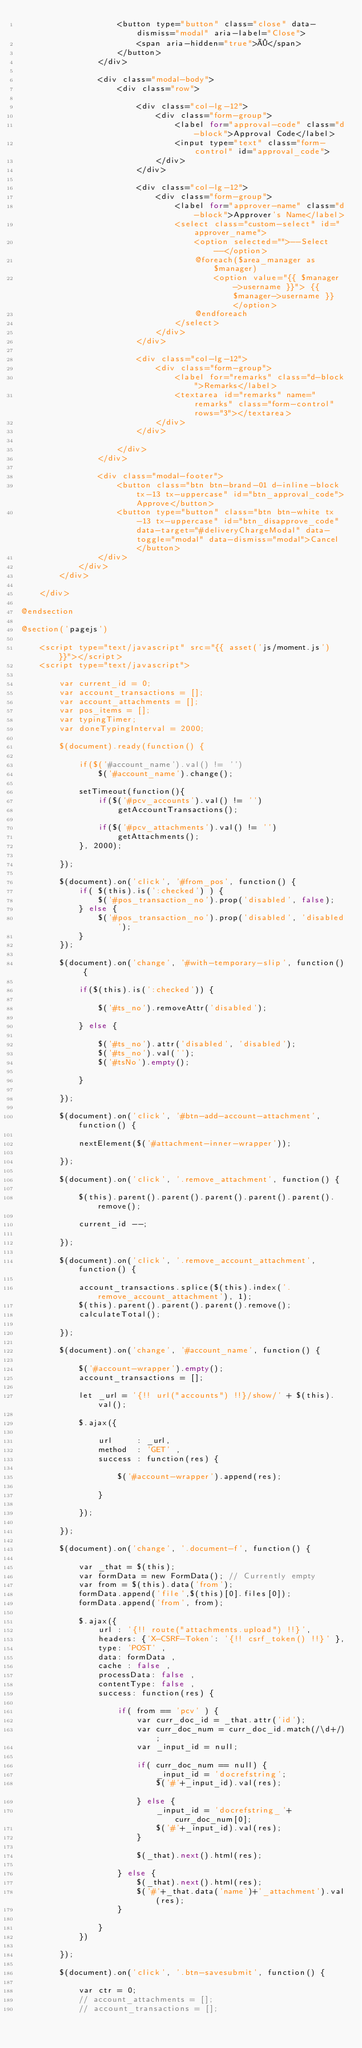<code> <loc_0><loc_0><loc_500><loc_500><_PHP_>					<button type="button" class="close" data-dismiss="modal" aria-label="Close">
						<span aria-hidden="true">×</span>
					</button>
				</div>

				<div class="modal-body">
					<div class="row">
						
						<div class="col-lg-12">
							<div class="form-group">
								<label for="approval-code" class="d-block">Approval Code</label>
								<input type="text" class="form-control" id="approval_code">
							</div>
						</div>

						<div class="col-lg-12">
							<div class="form-group">
								<label for="approver-name" class="d-block">Approver's Name</label>
								<select class="custom-select" id="approver_name">
									<option selected="">--Select--</option>
									@foreach($area_manager as $manager) 
										<option value="{{ $manager->username }}"> {{ $manager->username }} </option>
									@endforeach
								</select>
							</div>
						</div>

						<div class="col-lg-12">
							<div class="form-group">
								<label for="remarks" class="d-block">Remarks</label>
								<textarea id="remarks" name="remarks" class="form-control" rows="3"></textarea>
							</div>
						</div>

					</div>
				</div>

				<div class="modal-footer">
					<button class="btn btn-brand-01 d-inline-block tx-13 tx-uppercase" id="btn_approval_code">Approve</button>
					<button type="button" class="btn btn-white tx-13 tx-uppercase" id="btn_disapprove_code" data-target="#deliveryChargeModal" data-toggle="modal" data-dismiss="modal">Cancel</button>
				</div>
			</div>
		</div>

	</div>
	
@endsection

@section('pagejs')
	
	<script type="text/javascript" src="{{ asset('js/moment.js') }}"></script>
	<script type="text/javascript">
		
		var current_id = 0;
		var account_transactions = [];
		var account_attachments = [];
		var pos_items = [];
		var typingTimer;
		var doneTypingInterval = 2000;

		$(document).ready(function() {

			if($('#account_name').val() != '')
				$('#account_name').change();

			setTimeout(function(){
				if($('#pcv_accounts').val() != '')
					getAccountTransactions();

				if($('#pcv_attachments').val() != '')
					getAttachments();
			}, 2000);

		});

		$(document).on('click', '#from_pos', function() {
			if( $(this).is(':checked') ) {
				$('#pos_transaction_no').prop('disabled', false);
			} else {
				$('#pos_transaction_no').prop('disabled', 'disabled');
			}
		});

		$(document).on('change', '#with-temporary-slip', function() {

			if($(this).is(':checked')) {

				$('#ts_no').removeAttr('disabled');

			} else {

				$('#ts_no').attr('disabled', 'disabled');
				$('#ts_no').val('');
				$('#tsNo').empty();

			}			

		});

		$(document).on('click', '#btn-add-account-attachment', function() {

			nextElement($('#attachment-inner-wrapper'));

		});

		$(document).on('click', '.remove_attachment', function() {

			$(this).parent().parent().parent().parent().parent().remove();

			current_id --;

		});

		$(document).on('click', '.remove_account_attachment', function() {

			account_transactions.splice($(this).index('.remove_account_attachment'), 1);
			$(this).parent().parent().parent().remove();
			calculateTotal();

		});

		$(document).on('change', '#account_name', function() {

			$('#account-wrapper').empty();
			account_transactions = [];

			let _url = '{!! url("accounts") !!}/show/' + $(this).val();

			$.ajax({

				url 	: _url,
				method 	: 'GET' ,
				success : function(res) {

					$('#account-wrapper').append(res);

				}

			});

		});

		$(document).on('change', '.document-f', function() {

			var _that = $(this);
			var formData = new FormData(); // Currently empty
			var from = $(this).data('from');
			formData.append('file',$(this)[0].files[0]);
			formData.append('from', from);

			$.ajax({
				url : '{!! route("attachments.upload") !!}',
				headers: {'X-CSRF-Token': '{!! csrf_token() !!}' },
				type: 'POST' ,
				data: formData ,
				cache : false ,
				processData: false ,
				contentType: false ,
				success: function(res) {

					if( from == 'pcv' ) {
		 				var curr_doc_id = _that.attr('id');
						var curr_doc_num = curr_doc_id.match(/\d+/);
						var _input_id = null;

						if( curr_doc_num == null) {
							_input_id = 'docrefstring';
							$('#'+_input_id).val(res);				
						} else {
							_input_id = 'docrefstring_'+ curr_doc_num[0];
							$('#'+_input_id).val(res);
						}

			          	$(_that).next().html(res);

					} else {
						$(_that).next().html(res);
						$('#'+_that.data('name')+'_attachment').val(res);
					}

				}
			})

		});

		$(document).on('click', '.btn-savesubmit', function() {

			var ctr = 0;
			// account_attachments = [];
			// account_transactions = [];</code> 